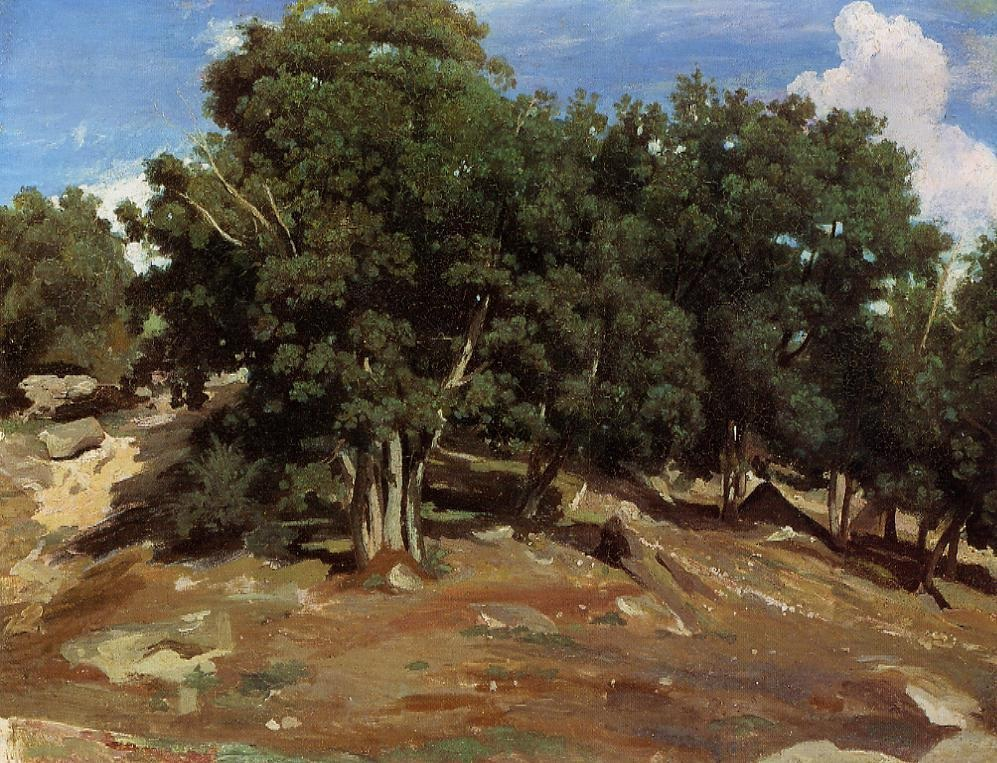Can you tell a short story about a day spent in this landscape? One sunny morning, Lily decided to explore the serene landscape she had always admired from afar. She set off up the rocky hillside, the gentle crunch of dirt and gravel under her feet echoing through the still air. As she walked, she marveled at the sturdy, towering trees reaching towards the sky, their leaves creating a vibrant patchwork of green. Finding a cozy spot under an ancient oak, Lily sat down and listened to the rustle of leaves and the distant call of birds. She took out a sketchbook and began to capture the natural beauty around her, the impressionist style of her drawings mirroring the landscape itself. As the sun began to set, casting a warm golden light over the hill, she packed up her things and made her way back home, her heart full of peace and inspiration from a day spent in harmony with nature. 